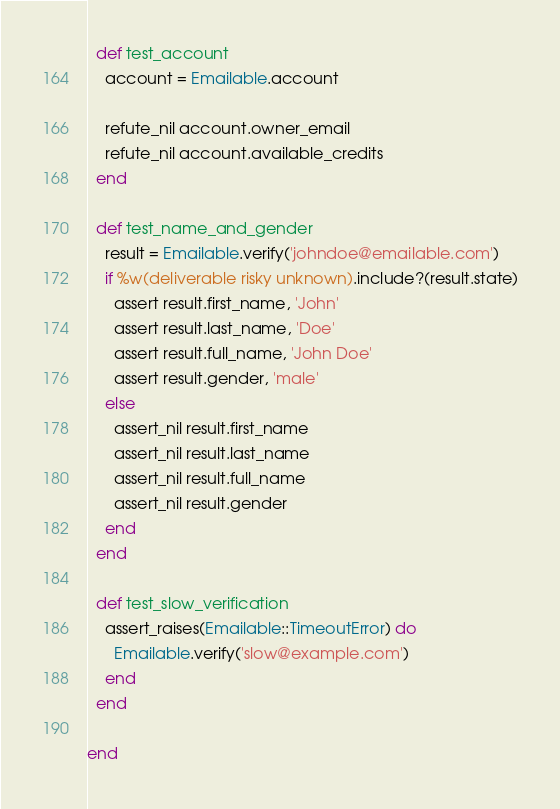Convert code to text. <code><loc_0><loc_0><loc_500><loc_500><_Ruby_>  def test_account
    account = Emailable.account

    refute_nil account.owner_email
    refute_nil account.available_credits
  end

  def test_name_and_gender
    result = Emailable.verify('johndoe@emailable.com')
    if %w(deliverable risky unknown).include?(result.state)
      assert result.first_name, 'John'
      assert result.last_name, 'Doe'
      assert result.full_name, 'John Doe'
      assert result.gender, 'male'
    else
      assert_nil result.first_name
      assert_nil result.last_name
      assert_nil result.full_name
      assert_nil result.gender
    end
  end

  def test_slow_verification
    assert_raises(Emailable::TimeoutError) do
      Emailable.verify('slow@example.com')
    end
  end

end
</code> 